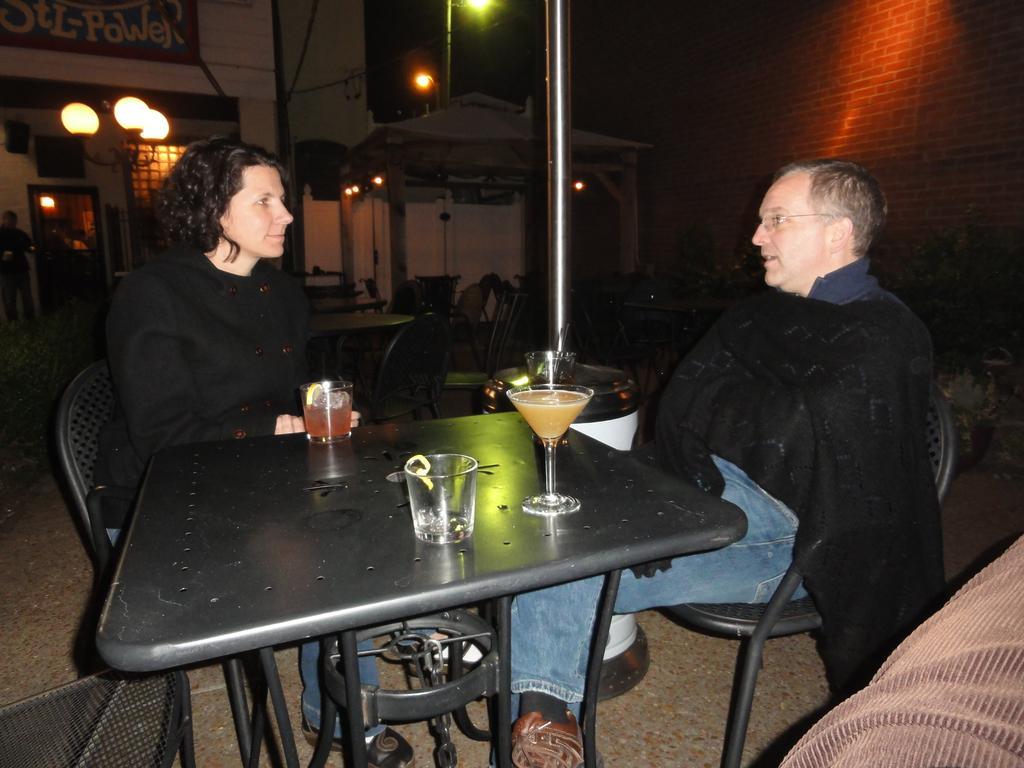Could you give a brief overview of what you see in this image? On the background of the picture we can see a building. This is a light. Here we can see two persons sitting and talking to each other. This is a table in black colour on which there are two drinking glasses. This is also a glass. 